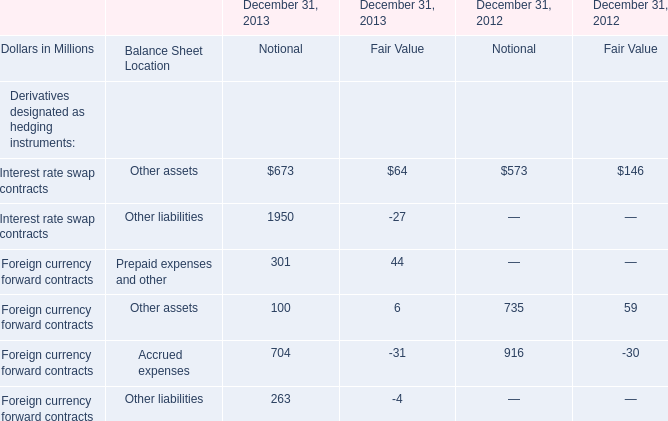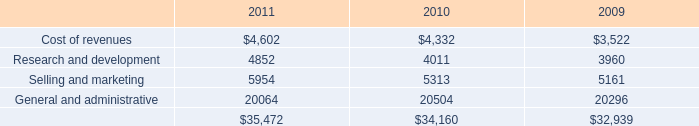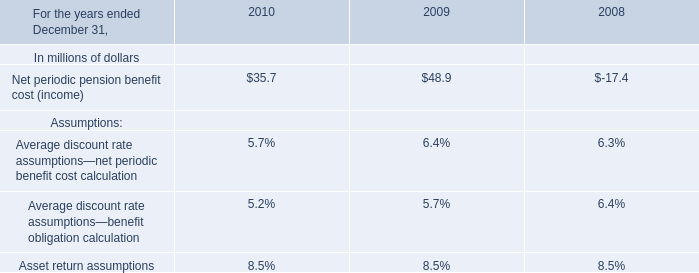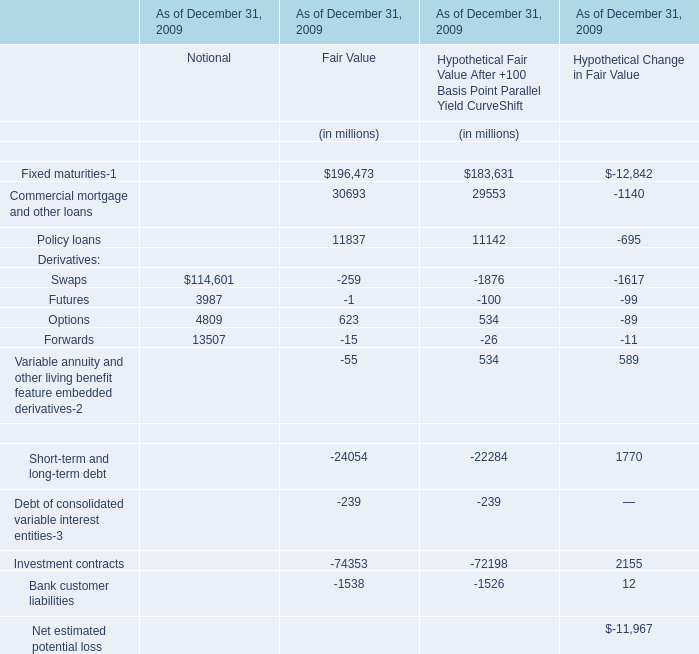What is the sum of Research and development in 2010 and Net periodic pension benefit cost (income) in 2009? (in million) 
Computations: (4011 + 48.9)
Answer: 4059.9. 